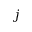Convert formula to latex. <formula><loc_0><loc_0><loc_500><loc_500>j</formula> 